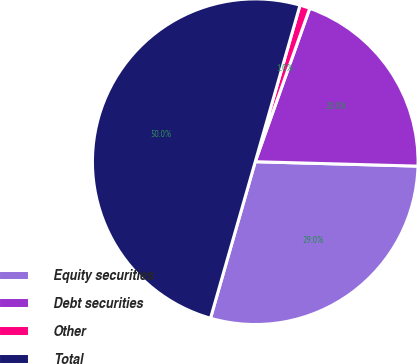Convert chart. <chart><loc_0><loc_0><loc_500><loc_500><pie_chart><fcel>Equity securities<fcel>Debt securities<fcel>Other<fcel>Total<nl><fcel>29.0%<fcel>20.0%<fcel>1.0%<fcel>50.0%<nl></chart> 